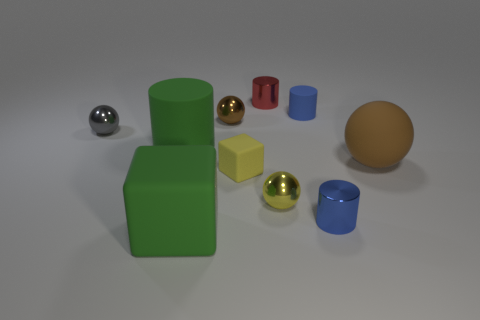Are there the same number of tiny shiny spheres right of the blue rubber cylinder and tiny red matte cylinders?
Your response must be concise. Yes. There is a cylinder that is the same color as the large matte cube; what is its size?
Offer a very short reply. Large. Are there any green cubes that have the same material as the large ball?
Offer a terse response. Yes. Do the tiny gray metallic thing on the left side of the red cylinder and the green object in front of the tiny yellow metallic sphere have the same shape?
Keep it short and to the point. No. Is there a green matte object?
Your response must be concise. Yes. There is a matte cylinder that is the same size as the red metal object; what is its color?
Keep it short and to the point. Blue. How many brown things are the same shape as the tiny yellow metallic object?
Keep it short and to the point. 2. Does the blue cylinder that is behind the small blue metallic thing have the same material as the red thing?
Your answer should be very brief. No. How many cylinders are either tiny blue matte things or big brown rubber things?
Provide a short and direct response. 1. There is a green object in front of the sphere in front of the brown object that is in front of the gray shiny thing; what shape is it?
Your answer should be very brief. Cube. 